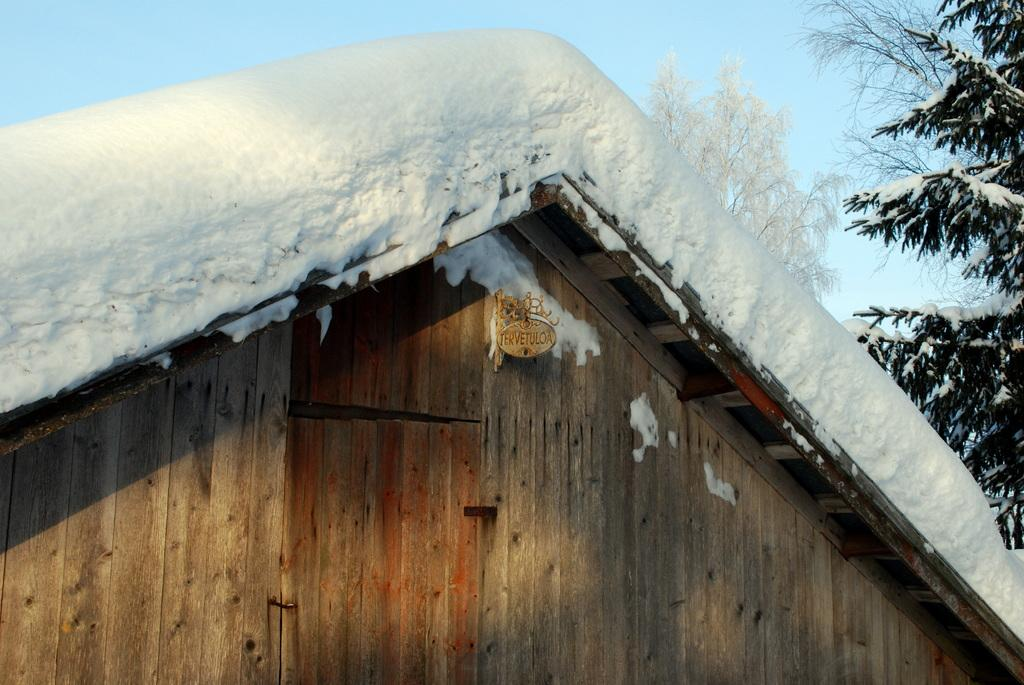What type of house is in the center of the image? There is a wooden house in the center of the image. What is covering the roof of the house? The house has snow on its roof. What can be seen in the background of the image? There is sky and trees visible in the background of the image. Can you see the smile on the icicle in the image? There is no icicle present in the image, and therefore no smile can be observed. 